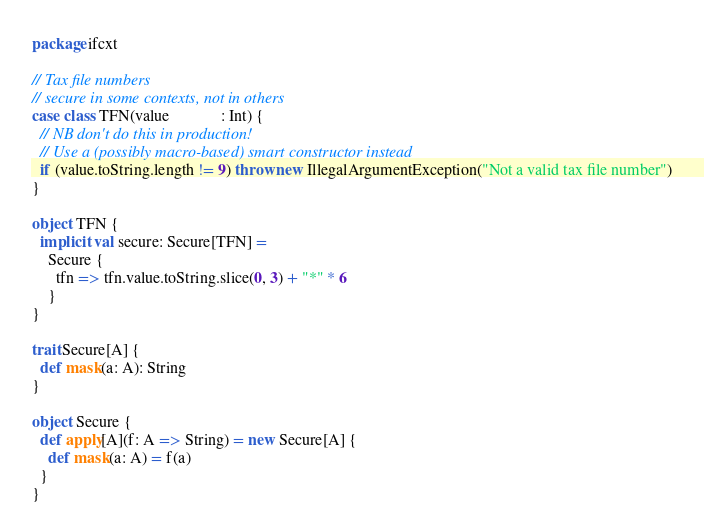Convert code to text. <code><loc_0><loc_0><loc_500><loc_500><_Scala_>package ifcxt

// Tax file numbers
// secure in some contexts, not in others
case class TFN(value             : Int) {
  // NB don't do this in production!
  // Use a (possibly macro-based) smart constructor instead
  if (value.toString.length != 9) throw new IllegalArgumentException("Not a valid tax file number")
}

object TFN {
  implicit val secure: Secure[TFN] =
    Secure {
      tfn => tfn.value.toString.slice(0, 3) + "*" * 6
    }
}

trait Secure[A] {
  def mask(a: A): String
}

object Secure {
  def apply[A](f: A => String) = new Secure[A] {
    def mask(a: A) = f(a)
  }
}
</code> 